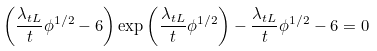<formula> <loc_0><loc_0><loc_500><loc_500>\left ( \frac { \lambda _ { t L } } { t } \phi ^ { 1 / 2 } - 6 \right ) \exp \left ( \frac { \lambda _ { t L } } { t } \phi ^ { 1 / 2 } \right ) - \frac { \lambda _ { t L } } { t } \phi ^ { 1 / 2 } - 6 = 0</formula> 